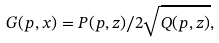<formula> <loc_0><loc_0><loc_500><loc_500>G ( p , x ) = P ( p , z ) / 2 \sqrt { Q ( p , z ) } ,</formula> 